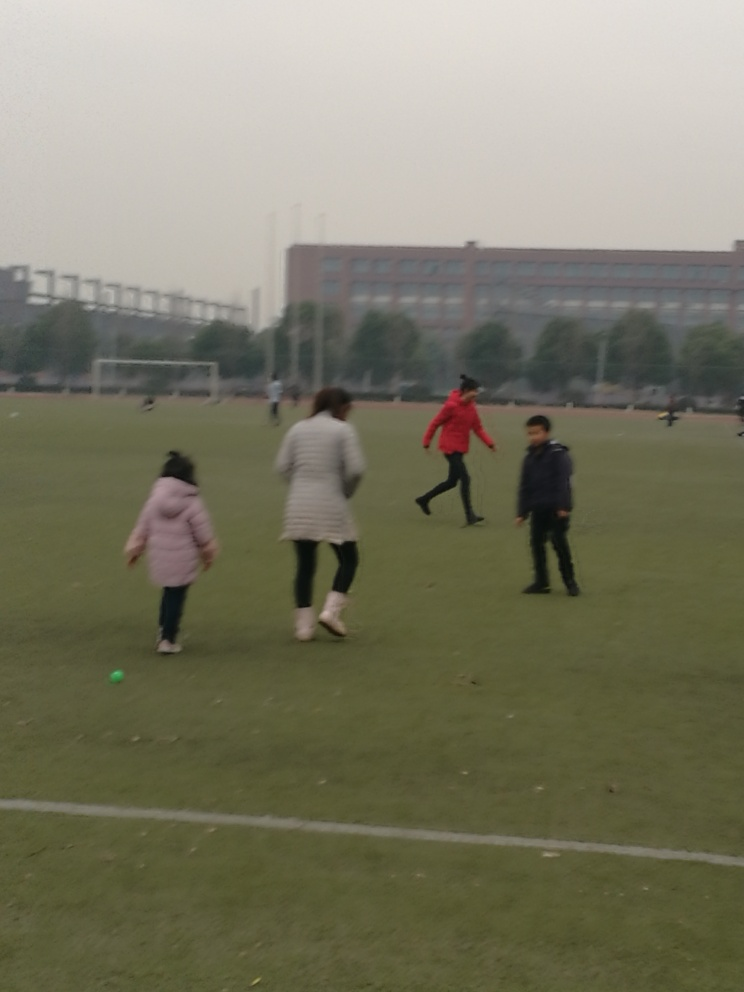What activity is taking place in the image? The image captures a group of individuals, possibly a family, engaged in recreational activities in an open field. The positioning and posture of the individuals suggest they might be playing a casual game or simply enjoying a walk together in the outdoors. 